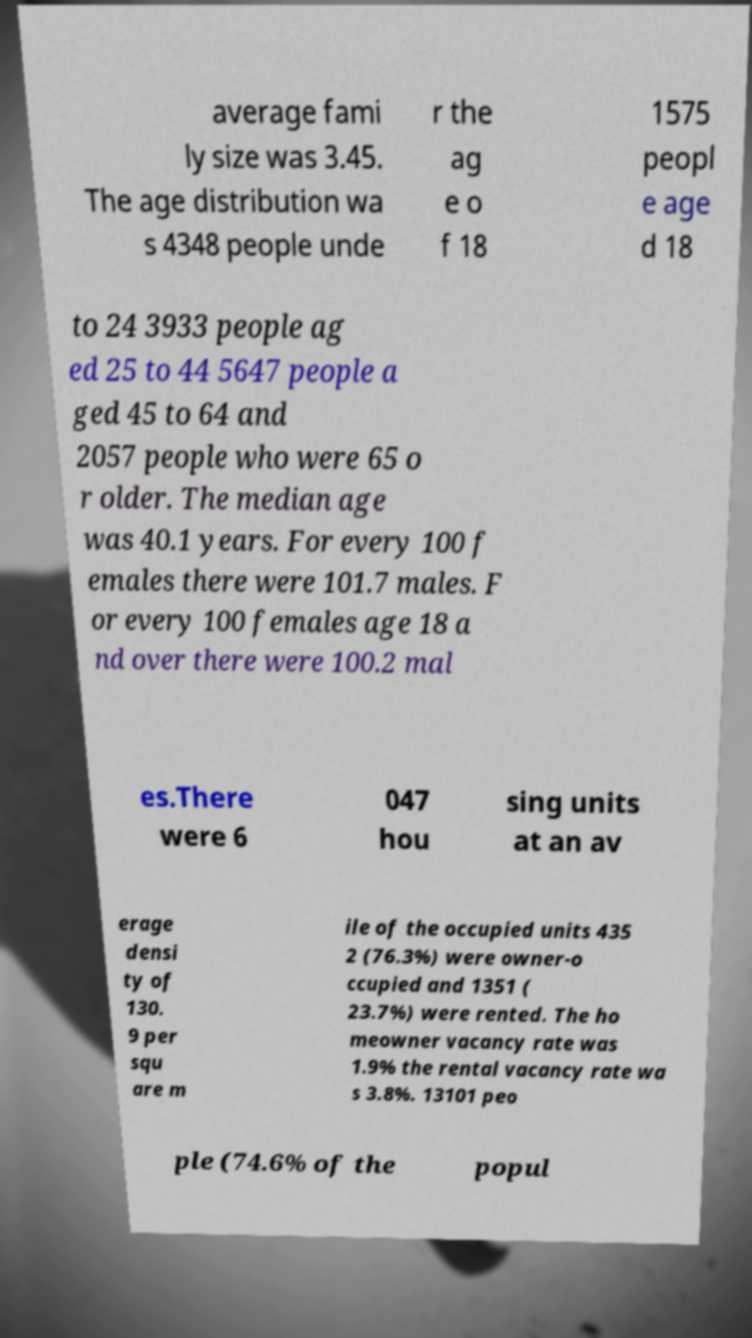Could you assist in decoding the text presented in this image and type it out clearly? average fami ly size was 3.45. The age distribution wa s 4348 people unde r the ag e o f 18 1575 peopl e age d 18 to 24 3933 people ag ed 25 to 44 5647 people a ged 45 to 64 and 2057 people who were 65 o r older. The median age was 40.1 years. For every 100 f emales there were 101.7 males. F or every 100 females age 18 a nd over there were 100.2 mal es.There were 6 047 hou sing units at an av erage densi ty of 130. 9 per squ are m ile of the occupied units 435 2 (76.3%) were owner-o ccupied and 1351 ( 23.7%) were rented. The ho meowner vacancy rate was 1.9% the rental vacancy rate wa s 3.8%. 13101 peo ple (74.6% of the popul 